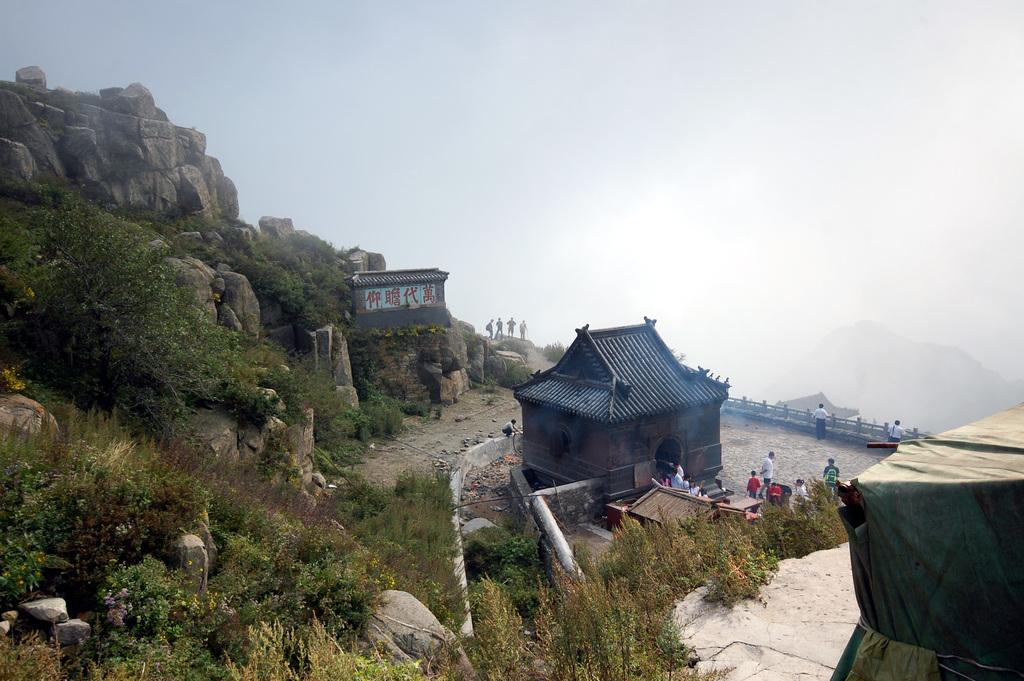What type of structure can be seen in the image? There is a house and a tent in the image. What natural feature is present in the image? There is a mountain in the image. Are there any trees on the mountain? Yes, there are trees on the mountain in the image. Can you describe the people in the image? There are people standing in the image. What safety feature is visible in the image? There is a railing in the image. What is visible in the background of the image? There is a mountain and the sky visible in the background of the image. What type of engine is powering the house in the image? There is no engine present in the image; it is a house and a tent situated near a mountain. What type of operation is being performed by the people in the image? There is no operation being performed by the people in the image; they are simply standing. 